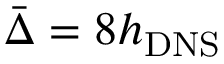<formula> <loc_0><loc_0><loc_500><loc_500>\bar { \Delta } = 8 h _ { D N S }</formula> 